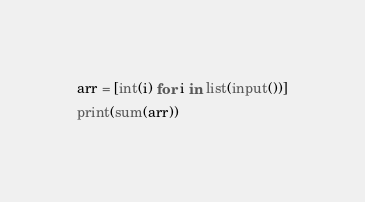<code> <loc_0><loc_0><loc_500><loc_500><_Python_>arr = [int(i) for i in list(input())]
print(sum(arr))</code> 